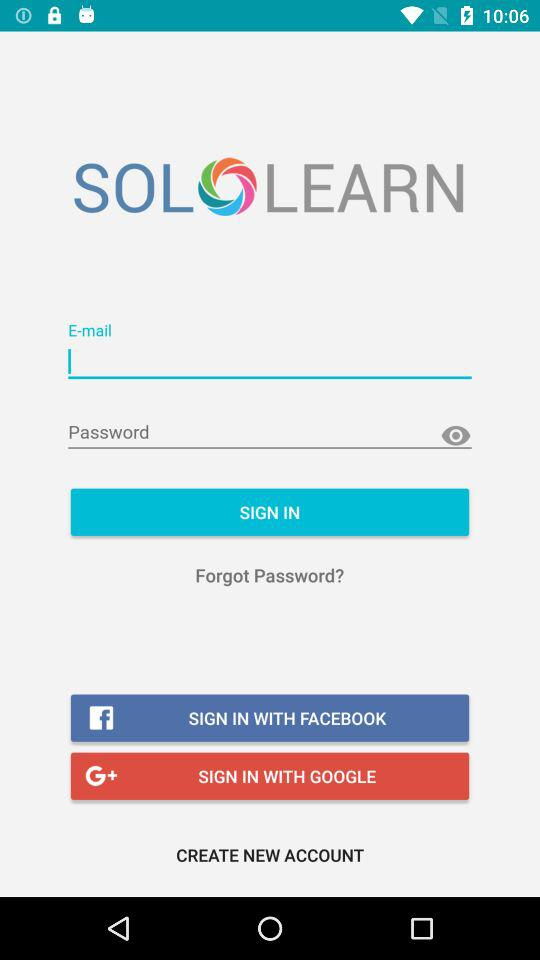Through which accounts can signing in be done? The signing in can be done through "E-mail", "FACEBOOK" and "GOOGLE". 